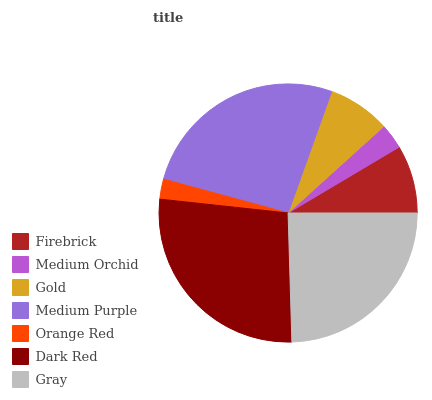Is Orange Red the minimum?
Answer yes or no. Yes. Is Dark Red the maximum?
Answer yes or no. Yes. Is Medium Orchid the minimum?
Answer yes or no. No. Is Medium Orchid the maximum?
Answer yes or no. No. Is Firebrick greater than Medium Orchid?
Answer yes or no. Yes. Is Medium Orchid less than Firebrick?
Answer yes or no. Yes. Is Medium Orchid greater than Firebrick?
Answer yes or no. No. Is Firebrick less than Medium Orchid?
Answer yes or no. No. Is Firebrick the high median?
Answer yes or no. Yes. Is Firebrick the low median?
Answer yes or no. Yes. Is Orange Red the high median?
Answer yes or no. No. Is Gray the low median?
Answer yes or no. No. 